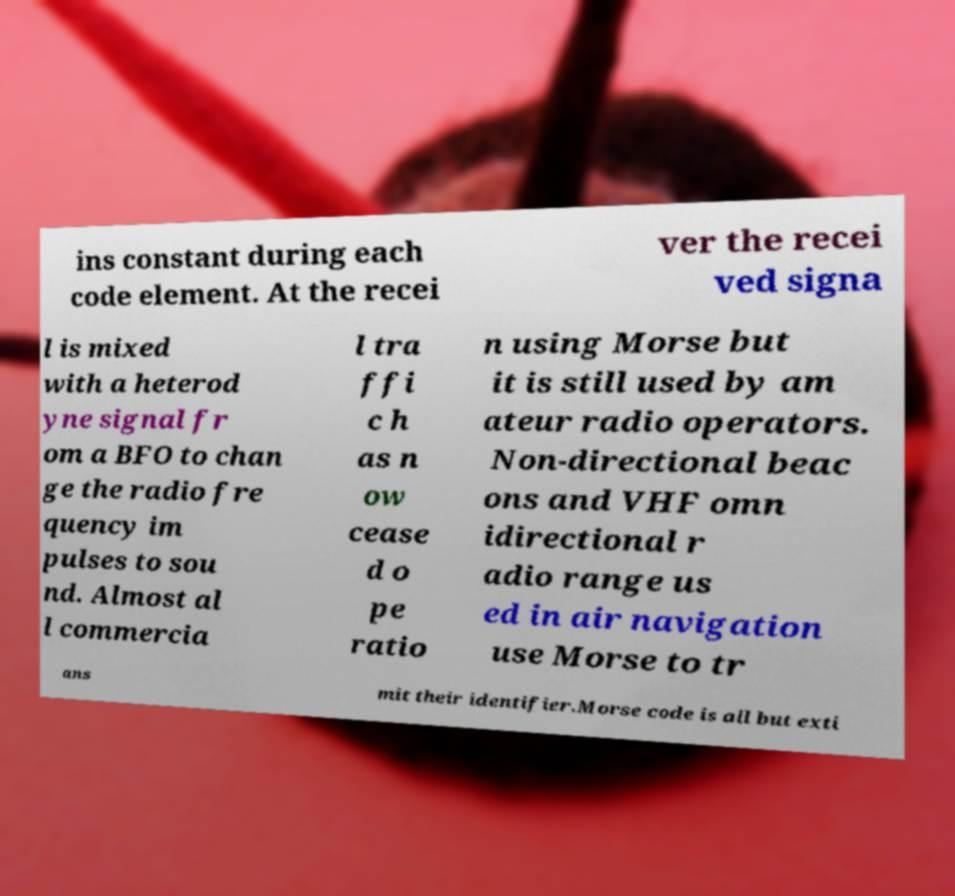Could you assist in decoding the text presented in this image and type it out clearly? ins constant during each code element. At the recei ver the recei ved signa l is mixed with a heterod yne signal fr om a BFO to chan ge the radio fre quency im pulses to sou nd. Almost al l commercia l tra ffi c h as n ow cease d o pe ratio n using Morse but it is still used by am ateur radio operators. Non-directional beac ons and VHF omn idirectional r adio range us ed in air navigation use Morse to tr ans mit their identifier.Morse code is all but exti 